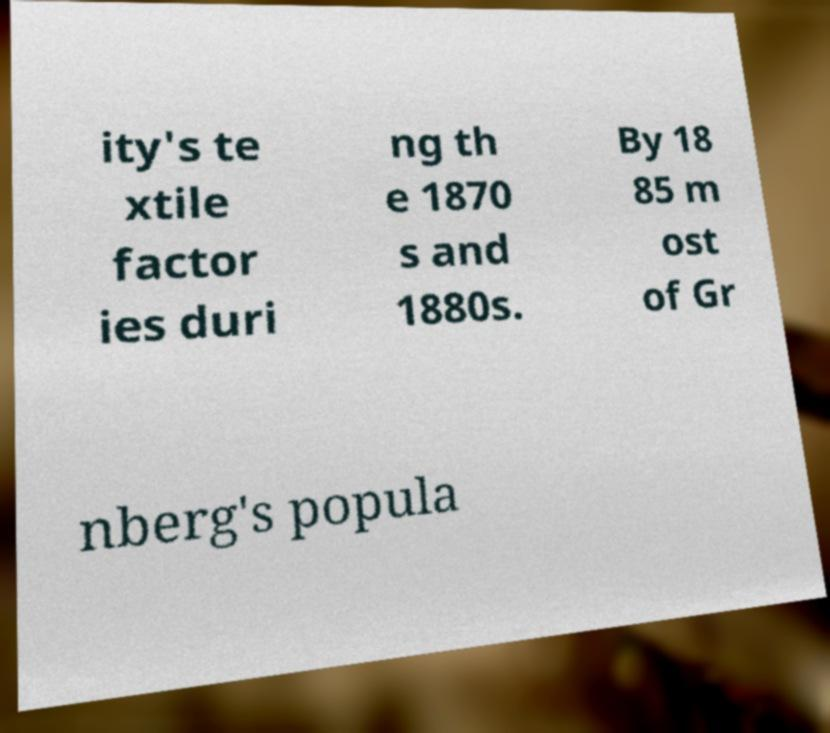Can you accurately transcribe the text from the provided image for me? ity's te xtile factor ies duri ng th e 1870 s and 1880s. By 18 85 m ost of Gr nberg's popula 